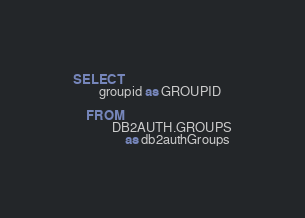Convert code to text. <code><loc_0><loc_0><loc_500><loc_500><_SQL_>SELECT
		groupid as GROUPID

	FROM
            DB2AUTH.GROUPS
                as db2authGroups</code> 